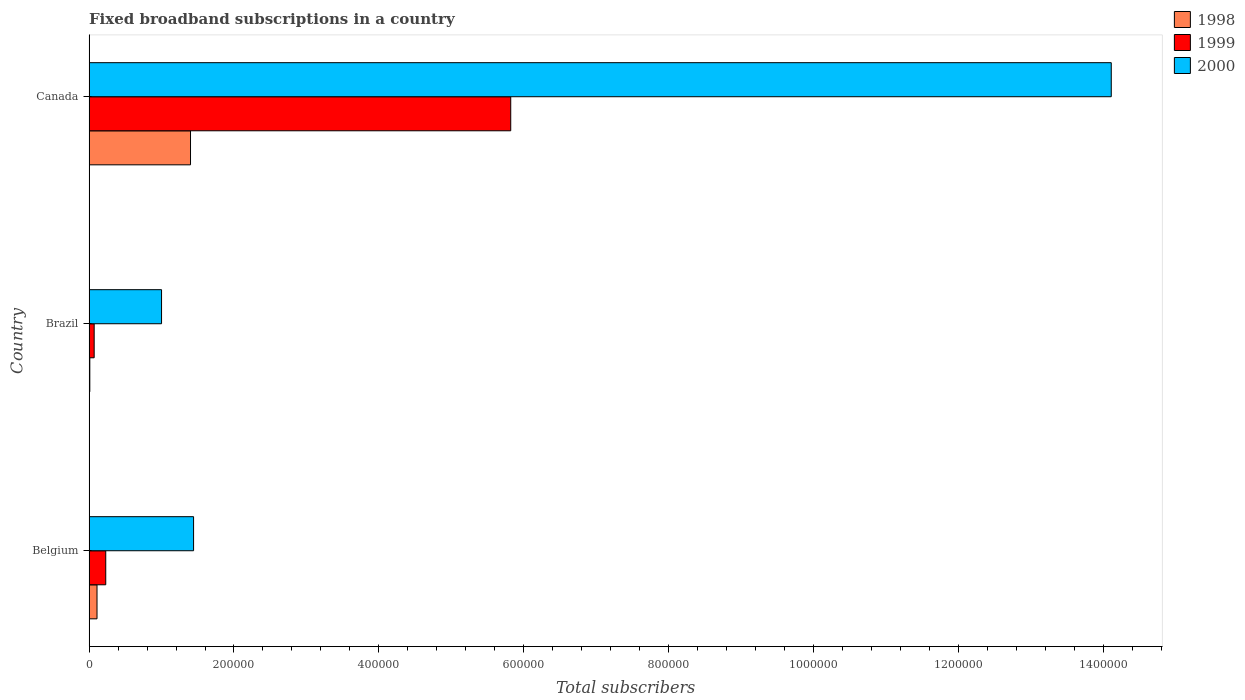How many different coloured bars are there?
Offer a terse response. 3. Are the number of bars on each tick of the Y-axis equal?
Ensure brevity in your answer.  Yes. How many bars are there on the 3rd tick from the top?
Give a very brief answer. 3. How many bars are there on the 1st tick from the bottom?
Give a very brief answer. 3. What is the label of the 3rd group of bars from the top?
Your answer should be very brief. Belgium. What is the number of broadband subscriptions in 1999 in Canada?
Your answer should be very brief. 5.82e+05. Across all countries, what is the maximum number of broadband subscriptions in 1998?
Provide a short and direct response. 1.40e+05. In which country was the number of broadband subscriptions in 1998 maximum?
Offer a very short reply. Canada. What is the total number of broadband subscriptions in 2000 in the graph?
Provide a succinct answer. 1.66e+06. What is the difference between the number of broadband subscriptions in 2000 in Belgium and that in Brazil?
Make the answer very short. 4.42e+04. What is the average number of broadband subscriptions in 1998 per country?
Make the answer very short. 5.06e+04. What is the difference between the number of broadband subscriptions in 2000 and number of broadband subscriptions in 1998 in Brazil?
Make the answer very short. 9.90e+04. What is the ratio of the number of broadband subscriptions in 2000 in Brazil to that in Canada?
Offer a very short reply. 0.07. Is the number of broadband subscriptions in 1998 in Brazil less than that in Canada?
Keep it short and to the point. Yes. What is the difference between the highest and the second highest number of broadband subscriptions in 2000?
Provide a short and direct response. 1.27e+06. What is the difference between the highest and the lowest number of broadband subscriptions in 2000?
Keep it short and to the point. 1.31e+06. In how many countries, is the number of broadband subscriptions in 1999 greater than the average number of broadband subscriptions in 1999 taken over all countries?
Keep it short and to the point. 1. Is the sum of the number of broadband subscriptions in 2000 in Belgium and Brazil greater than the maximum number of broadband subscriptions in 1998 across all countries?
Ensure brevity in your answer.  Yes. What does the 2nd bar from the top in Brazil represents?
Offer a very short reply. 1999. What does the 2nd bar from the bottom in Canada represents?
Keep it short and to the point. 1999. Is it the case that in every country, the sum of the number of broadband subscriptions in 2000 and number of broadband subscriptions in 1999 is greater than the number of broadband subscriptions in 1998?
Ensure brevity in your answer.  Yes. How many countries are there in the graph?
Provide a short and direct response. 3. What is the difference between two consecutive major ticks on the X-axis?
Keep it short and to the point. 2.00e+05. Are the values on the major ticks of X-axis written in scientific E-notation?
Ensure brevity in your answer.  No. Where does the legend appear in the graph?
Keep it short and to the point. Top right. How are the legend labels stacked?
Keep it short and to the point. Vertical. What is the title of the graph?
Your response must be concise. Fixed broadband subscriptions in a country. Does "1991" appear as one of the legend labels in the graph?
Your answer should be very brief. No. What is the label or title of the X-axis?
Your response must be concise. Total subscribers. What is the Total subscribers of 1998 in Belgium?
Your answer should be very brief. 1.09e+04. What is the Total subscribers in 1999 in Belgium?
Your response must be concise. 2.30e+04. What is the Total subscribers in 2000 in Belgium?
Provide a short and direct response. 1.44e+05. What is the Total subscribers in 1998 in Brazil?
Give a very brief answer. 1000. What is the Total subscribers in 1999 in Brazil?
Make the answer very short. 7000. What is the Total subscribers of 2000 in Brazil?
Provide a succinct answer. 1.00e+05. What is the Total subscribers of 1998 in Canada?
Make the answer very short. 1.40e+05. What is the Total subscribers of 1999 in Canada?
Make the answer very short. 5.82e+05. What is the Total subscribers of 2000 in Canada?
Ensure brevity in your answer.  1.41e+06. Across all countries, what is the maximum Total subscribers in 1998?
Your answer should be compact. 1.40e+05. Across all countries, what is the maximum Total subscribers of 1999?
Your answer should be very brief. 5.82e+05. Across all countries, what is the maximum Total subscribers of 2000?
Your answer should be very brief. 1.41e+06. Across all countries, what is the minimum Total subscribers of 1999?
Provide a short and direct response. 7000. Across all countries, what is the minimum Total subscribers of 2000?
Give a very brief answer. 1.00e+05. What is the total Total subscribers of 1998 in the graph?
Offer a very short reply. 1.52e+05. What is the total Total subscribers in 1999 in the graph?
Ensure brevity in your answer.  6.12e+05. What is the total Total subscribers of 2000 in the graph?
Give a very brief answer. 1.66e+06. What is the difference between the Total subscribers of 1998 in Belgium and that in Brazil?
Ensure brevity in your answer.  9924. What is the difference between the Total subscribers in 1999 in Belgium and that in Brazil?
Provide a succinct answer. 1.60e+04. What is the difference between the Total subscribers in 2000 in Belgium and that in Brazil?
Your answer should be compact. 4.42e+04. What is the difference between the Total subscribers in 1998 in Belgium and that in Canada?
Offer a very short reply. -1.29e+05. What is the difference between the Total subscribers of 1999 in Belgium and that in Canada?
Keep it short and to the point. -5.59e+05. What is the difference between the Total subscribers in 2000 in Belgium and that in Canada?
Offer a very short reply. -1.27e+06. What is the difference between the Total subscribers of 1998 in Brazil and that in Canada?
Keep it short and to the point. -1.39e+05. What is the difference between the Total subscribers in 1999 in Brazil and that in Canada?
Give a very brief answer. -5.75e+05. What is the difference between the Total subscribers in 2000 in Brazil and that in Canada?
Your response must be concise. -1.31e+06. What is the difference between the Total subscribers in 1998 in Belgium and the Total subscribers in 1999 in Brazil?
Your answer should be very brief. 3924. What is the difference between the Total subscribers in 1998 in Belgium and the Total subscribers in 2000 in Brazil?
Your response must be concise. -8.91e+04. What is the difference between the Total subscribers of 1999 in Belgium and the Total subscribers of 2000 in Brazil?
Your answer should be very brief. -7.70e+04. What is the difference between the Total subscribers of 1998 in Belgium and the Total subscribers of 1999 in Canada?
Your answer should be very brief. -5.71e+05. What is the difference between the Total subscribers in 1998 in Belgium and the Total subscribers in 2000 in Canada?
Your answer should be compact. -1.40e+06. What is the difference between the Total subscribers in 1999 in Belgium and the Total subscribers in 2000 in Canada?
Keep it short and to the point. -1.39e+06. What is the difference between the Total subscribers of 1998 in Brazil and the Total subscribers of 1999 in Canada?
Offer a terse response. -5.81e+05. What is the difference between the Total subscribers in 1998 in Brazil and the Total subscribers in 2000 in Canada?
Ensure brevity in your answer.  -1.41e+06. What is the difference between the Total subscribers of 1999 in Brazil and the Total subscribers of 2000 in Canada?
Offer a terse response. -1.40e+06. What is the average Total subscribers of 1998 per country?
Provide a short and direct response. 5.06e+04. What is the average Total subscribers of 1999 per country?
Your response must be concise. 2.04e+05. What is the average Total subscribers of 2000 per country?
Keep it short and to the point. 5.52e+05. What is the difference between the Total subscribers in 1998 and Total subscribers in 1999 in Belgium?
Your answer should be very brief. -1.21e+04. What is the difference between the Total subscribers of 1998 and Total subscribers of 2000 in Belgium?
Offer a very short reply. -1.33e+05. What is the difference between the Total subscribers in 1999 and Total subscribers in 2000 in Belgium?
Keep it short and to the point. -1.21e+05. What is the difference between the Total subscribers in 1998 and Total subscribers in 1999 in Brazil?
Ensure brevity in your answer.  -6000. What is the difference between the Total subscribers of 1998 and Total subscribers of 2000 in Brazil?
Offer a very short reply. -9.90e+04. What is the difference between the Total subscribers of 1999 and Total subscribers of 2000 in Brazil?
Keep it short and to the point. -9.30e+04. What is the difference between the Total subscribers of 1998 and Total subscribers of 1999 in Canada?
Provide a succinct answer. -4.42e+05. What is the difference between the Total subscribers of 1998 and Total subscribers of 2000 in Canada?
Your response must be concise. -1.27e+06. What is the difference between the Total subscribers in 1999 and Total subscribers in 2000 in Canada?
Offer a very short reply. -8.29e+05. What is the ratio of the Total subscribers in 1998 in Belgium to that in Brazil?
Keep it short and to the point. 10.92. What is the ratio of the Total subscribers of 1999 in Belgium to that in Brazil?
Make the answer very short. 3.29. What is the ratio of the Total subscribers of 2000 in Belgium to that in Brazil?
Provide a succinct answer. 1.44. What is the ratio of the Total subscribers in 1998 in Belgium to that in Canada?
Ensure brevity in your answer.  0.08. What is the ratio of the Total subscribers of 1999 in Belgium to that in Canada?
Provide a short and direct response. 0.04. What is the ratio of the Total subscribers in 2000 in Belgium to that in Canada?
Provide a short and direct response. 0.1. What is the ratio of the Total subscribers in 1998 in Brazil to that in Canada?
Provide a short and direct response. 0.01. What is the ratio of the Total subscribers of 1999 in Brazil to that in Canada?
Ensure brevity in your answer.  0.01. What is the ratio of the Total subscribers of 2000 in Brazil to that in Canada?
Provide a succinct answer. 0.07. What is the difference between the highest and the second highest Total subscribers of 1998?
Offer a terse response. 1.29e+05. What is the difference between the highest and the second highest Total subscribers of 1999?
Offer a very short reply. 5.59e+05. What is the difference between the highest and the second highest Total subscribers in 2000?
Your answer should be very brief. 1.27e+06. What is the difference between the highest and the lowest Total subscribers in 1998?
Provide a succinct answer. 1.39e+05. What is the difference between the highest and the lowest Total subscribers in 1999?
Your response must be concise. 5.75e+05. What is the difference between the highest and the lowest Total subscribers in 2000?
Your response must be concise. 1.31e+06. 